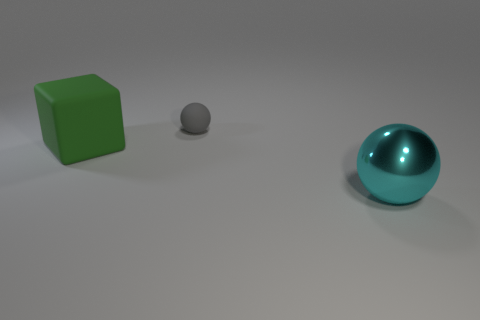Add 3 green matte objects. How many objects exist? 6 Add 1 big spheres. How many big spheres exist? 2 Subtract all gray balls. How many balls are left? 1 Subtract 0 blue cubes. How many objects are left? 3 Subtract all cubes. How many objects are left? 2 Subtract all purple cubes. Subtract all yellow cylinders. How many cubes are left? 1 Subtract all red cubes. How many cyan balls are left? 1 Subtract all large things. Subtract all large brown cylinders. How many objects are left? 1 Add 3 small spheres. How many small spheres are left? 4 